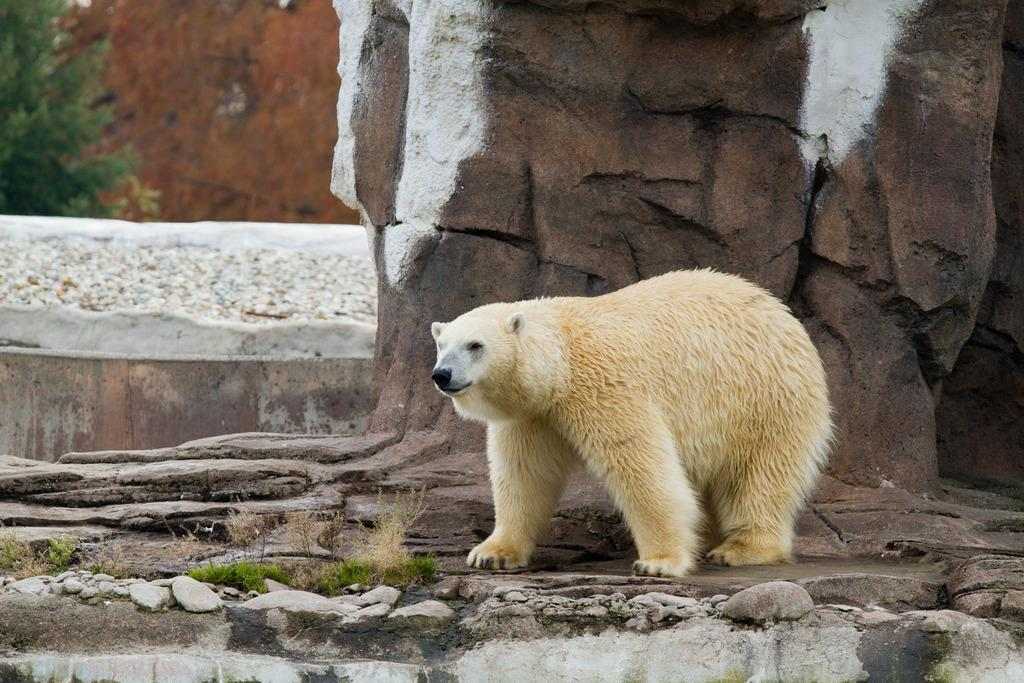What type of animal is in the image? There is a white polar bear in the image. What is the polar bear standing near? The polar bear is standing near stones and grass. What can be seen in the background of the image? There are stone walls visible in the background. Where is the tree located in the image? There is a tree in the top left corner of the image. What type of wool is the polar bear wearing in the image? The polar bear is not wearing any wool in the image; it is a wild animal in its natural habitat. 